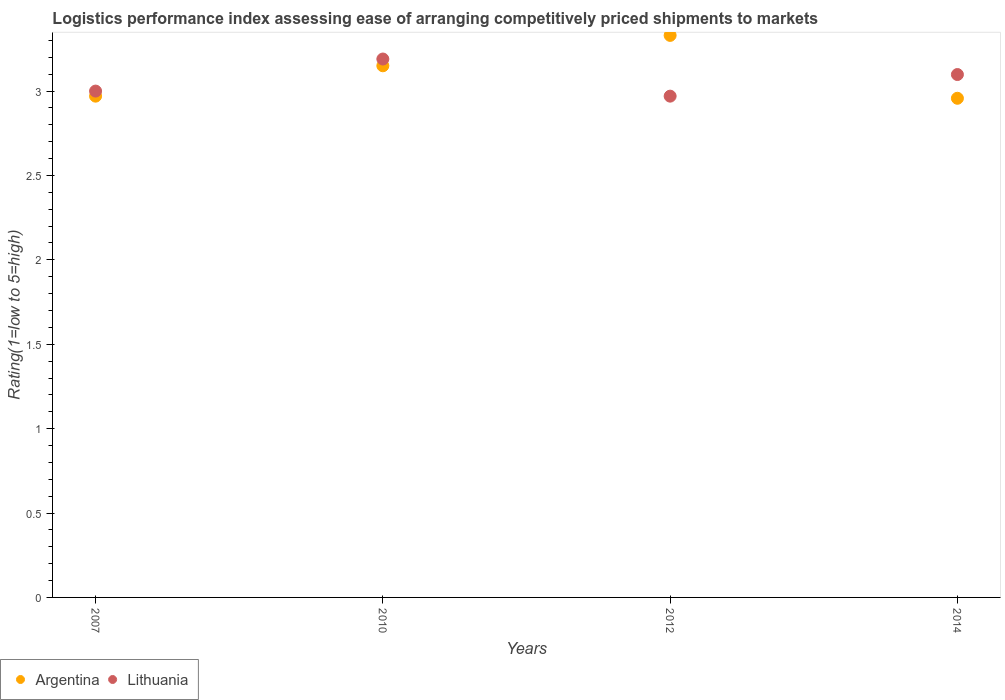How many different coloured dotlines are there?
Give a very brief answer. 2. Is the number of dotlines equal to the number of legend labels?
Provide a short and direct response. Yes. Across all years, what is the maximum Logistic performance index in Argentina?
Offer a terse response. 3.33. Across all years, what is the minimum Logistic performance index in Argentina?
Offer a very short reply. 2.96. In which year was the Logistic performance index in Argentina minimum?
Offer a very short reply. 2014. What is the total Logistic performance index in Argentina in the graph?
Keep it short and to the point. 12.41. What is the difference between the Logistic performance index in Argentina in 2010 and that in 2014?
Provide a short and direct response. 0.19. What is the difference between the Logistic performance index in Lithuania in 2014 and the Logistic performance index in Argentina in 2012?
Your answer should be very brief. -0.23. What is the average Logistic performance index in Argentina per year?
Make the answer very short. 3.1. In the year 2012, what is the difference between the Logistic performance index in Lithuania and Logistic performance index in Argentina?
Keep it short and to the point. -0.36. In how many years, is the Logistic performance index in Argentina greater than 2.9?
Your response must be concise. 4. What is the ratio of the Logistic performance index in Argentina in 2007 to that in 2014?
Provide a short and direct response. 1. Is the Logistic performance index in Argentina in 2010 less than that in 2014?
Offer a terse response. No. Is the difference between the Logistic performance index in Lithuania in 2012 and 2014 greater than the difference between the Logistic performance index in Argentina in 2012 and 2014?
Make the answer very short. No. What is the difference between the highest and the second highest Logistic performance index in Argentina?
Your answer should be very brief. 0.18. What is the difference between the highest and the lowest Logistic performance index in Argentina?
Provide a short and direct response. 0.37. Is the sum of the Logistic performance index in Lithuania in 2007 and 2012 greater than the maximum Logistic performance index in Argentina across all years?
Your answer should be very brief. Yes. Does the Logistic performance index in Lithuania monotonically increase over the years?
Your response must be concise. No. Is the Logistic performance index in Argentina strictly greater than the Logistic performance index in Lithuania over the years?
Offer a terse response. No. How many dotlines are there?
Keep it short and to the point. 2. What is the difference between two consecutive major ticks on the Y-axis?
Your answer should be very brief. 0.5. Does the graph contain grids?
Your answer should be compact. No. How are the legend labels stacked?
Provide a short and direct response. Horizontal. What is the title of the graph?
Provide a short and direct response. Logistics performance index assessing ease of arranging competitively priced shipments to markets. What is the label or title of the Y-axis?
Your answer should be very brief. Rating(1=low to 5=high). What is the Rating(1=low to 5=high) of Argentina in 2007?
Your answer should be compact. 2.97. What is the Rating(1=low to 5=high) of Argentina in 2010?
Keep it short and to the point. 3.15. What is the Rating(1=low to 5=high) in Lithuania in 2010?
Provide a short and direct response. 3.19. What is the Rating(1=low to 5=high) of Argentina in 2012?
Give a very brief answer. 3.33. What is the Rating(1=low to 5=high) of Lithuania in 2012?
Your answer should be compact. 2.97. What is the Rating(1=low to 5=high) in Argentina in 2014?
Your response must be concise. 2.96. What is the Rating(1=low to 5=high) in Lithuania in 2014?
Give a very brief answer. 3.1. Across all years, what is the maximum Rating(1=low to 5=high) of Argentina?
Offer a very short reply. 3.33. Across all years, what is the maximum Rating(1=low to 5=high) in Lithuania?
Provide a short and direct response. 3.19. Across all years, what is the minimum Rating(1=low to 5=high) in Argentina?
Make the answer very short. 2.96. Across all years, what is the minimum Rating(1=low to 5=high) of Lithuania?
Your response must be concise. 2.97. What is the total Rating(1=low to 5=high) in Argentina in the graph?
Provide a short and direct response. 12.41. What is the total Rating(1=low to 5=high) in Lithuania in the graph?
Your answer should be very brief. 12.26. What is the difference between the Rating(1=low to 5=high) of Argentina in 2007 and that in 2010?
Offer a terse response. -0.18. What is the difference between the Rating(1=low to 5=high) in Lithuania in 2007 and that in 2010?
Offer a terse response. -0.19. What is the difference between the Rating(1=low to 5=high) of Argentina in 2007 and that in 2012?
Provide a succinct answer. -0.36. What is the difference between the Rating(1=low to 5=high) of Lithuania in 2007 and that in 2012?
Provide a succinct answer. 0.03. What is the difference between the Rating(1=low to 5=high) of Argentina in 2007 and that in 2014?
Offer a terse response. 0.01. What is the difference between the Rating(1=low to 5=high) of Lithuania in 2007 and that in 2014?
Provide a succinct answer. -0.1. What is the difference between the Rating(1=low to 5=high) in Argentina in 2010 and that in 2012?
Offer a very short reply. -0.18. What is the difference between the Rating(1=low to 5=high) of Lithuania in 2010 and that in 2012?
Provide a short and direct response. 0.22. What is the difference between the Rating(1=low to 5=high) of Argentina in 2010 and that in 2014?
Your response must be concise. 0.19. What is the difference between the Rating(1=low to 5=high) in Lithuania in 2010 and that in 2014?
Ensure brevity in your answer.  0.09. What is the difference between the Rating(1=low to 5=high) of Argentina in 2012 and that in 2014?
Provide a succinct answer. 0.37. What is the difference between the Rating(1=low to 5=high) of Lithuania in 2012 and that in 2014?
Your response must be concise. -0.13. What is the difference between the Rating(1=low to 5=high) in Argentina in 2007 and the Rating(1=low to 5=high) in Lithuania in 2010?
Keep it short and to the point. -0.22. What is the difference between the Rating(1=low to 5=high) of Argentina in 2007 and the Rating(1=low to 5=high) of Lithuania in 2012?
Give a very brief answer. 0. What is the difference between the Rating(1=low to 5=high) in Argentina in 2007 and the Rating(1=low to 5=high) in Lithuania in 2014?
Offer a terse response. -0.13. What is the difference between the Rating(1=low to 5=high) in Argentina in 2010 and the Rating(1=low to 5=high) in Lithuania in 2012?
Provide a short and direct response. 0.18. What is the difference between the Rating(1=low to 5=high) of Argentina in 2010 and the Rating(1=low to 5=high) of Lithuania in 2014?
Provide a succinct answer. 0.05. What is the difference between the Rating(1=low to 5=high) in Argentina in 2012 and the Rating(1=low to 5=high) in Lithuania in 2014?
Ensure brevity in your answer.  0.23. What is the average Rating(1=low to 5=high) in Argentina per year?
Provide a short and direct response. 3.1. What is the average Rating(1=low to 5=high) of Lithuania per year?
Your response must be concise. 3.06. In the year 2007, what is the difference between the Rating(1=low to 5=high) of Argentina and Rating(1=low to 5=high) of Lithuania?
Provide a short and direct response. -0.03. In the year 2010, what is the difference between the Rating(1=low to 5=high) of Argentina and Rating(1=low to 5=high) of Lithuania?
Keep it short and to the point. -0.04. In the year 2012, what is the difference between the Rating(1=low to 5=high) of Argentina and Rating(1=low to 5=high) of Lithuania?
Make the answer very short. 0.36. In the year 2014, what is the difference between the Rating(1=low to 5=high) in Argentina and Rating(1=low to 5=high) in Lithuania?
Offer a terse response. -0.14. What is the ratio of the Rating(1=low to 5=high) in Argentina in 2007 to that in 2010?
Provide a short and direct response. 0.94. What is the ratio of the Rating(1=low to 5=high) of Lithuania in 2007 to that in 2010?
Offer a terse response. 0.94. What is the ratio of the Rating(1=low to 5=high) in Argentina in 2007 to that in 2012?
Ensure brevity in your answer.  0.89. What is the ratio of the Rating(1=low to 5=high) in Lithuania in 2007 to that in 2012?
Make the answer very short. 1.01. What is the ratio of the Rating(1=low to 5=high) in Argentina in 2007 to that in 2014?
Your response must be concise. 1. What is the ratio of the Rating(1=low to 5=high) in Lithuania in 2007 to that in 2014?
Provide a short and direct response. 0.97. What is the ratio of the Rating(1=low to 5=high) in Argentina in 2010 to that in 2012?
Give a very brief answer. 0.95. What is the ratio of the Rating(1=low to 5=high) of Lithuania in 2010 to that in 2012?
Your answer should be compact. 1.07. What is the ratio of the Rating(1=low to 5=high) of Argentina in 2010 to that in 2014?
Your answer should be compact. 1.07. What is the ratio of the Rating(1=low to 5=high) of Lithuania in 2010 to that in 2014?
Offer a terse response. 1.03. What is the ratio of the Rating(1=low to 5=high) in Argentina in 2012 to that in 2014?
Provide a succinct answer. 1.13. What is the ratio of the Rating(1=low to 5=high) of Lithuania in 2012 to that in 2014?
Your answer should be very brief. 0.96. What is the difference between the highest and the second highest Rating(1=low to 5=high) of Argentina?
Provide a succinct answer. 0.18. What is the difference between the highest and the second highest Rating(1=low to 5=high) of Lithuania?
Give a very brief answer. 0.09. What is the difference between the highest and the lowest Rating(1=low to 5=high) of Argentina?
Make the answer very short. 0.37. What is the difference between the highest and the lowest Rating(1=low to 5=high) of Lithuania?
Make the answer very short. 0.22. 